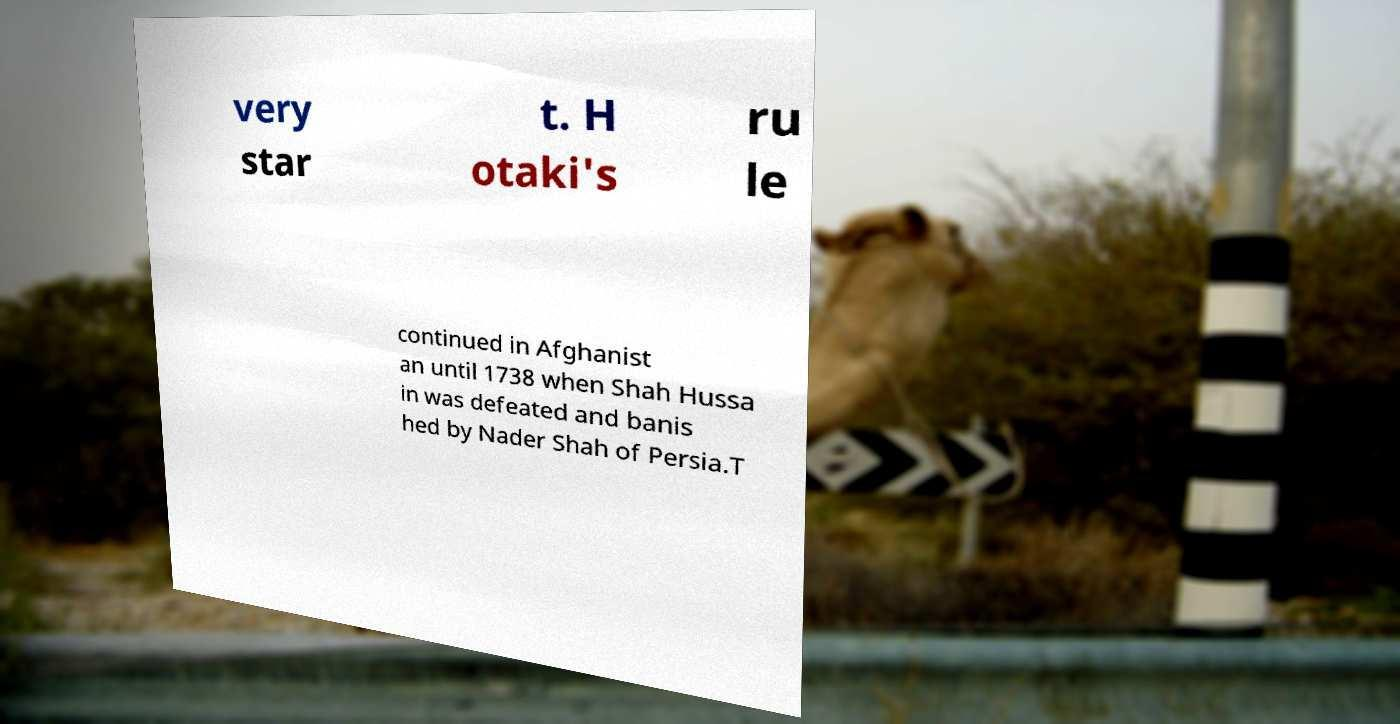Can you read and provide the text displayed in the image?This photo seems to have some interesting text. Can you extract and type it out for me? very star t. H otaki's ru le continued in Afghanist an until 1738 when Shah Hussa in was defeated and banis hed by Nader Shah of Persia.T 